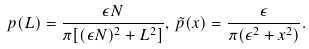<formula> <loc_0><loc_0><loc_500><loc_500>p ( L ) = \frac { \epsilon N } { \pi [ ( \epsilon N ) ^ { 2 } + L ^ { 2 } ] } , \, \tilde { p } ( x ) = \frac { \epsilon } { \pi ( \epsilon ^ { 2 } + x ^ { 2 } ) } .</formula> 